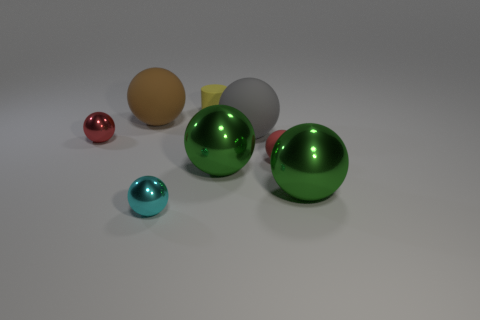There is a big sphere that is left of the gray rubber thing and in front of the large brown thing; what is its material? The big sphere appears to have a reflective surface with a tint of green, which suggests that it could be made of a polished metal, such as anodized aluminum, that has been colored to achieve a greenish hue. Its surface properties are not indicative of a matte material, so metal is a reasonable assumption. 